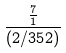<formula> <loc_0><loc_0><loc_500><loc_500>\frac { \frac { 7 } { 1 } } { ( 2 / 3 5 2 ) }</formula> 